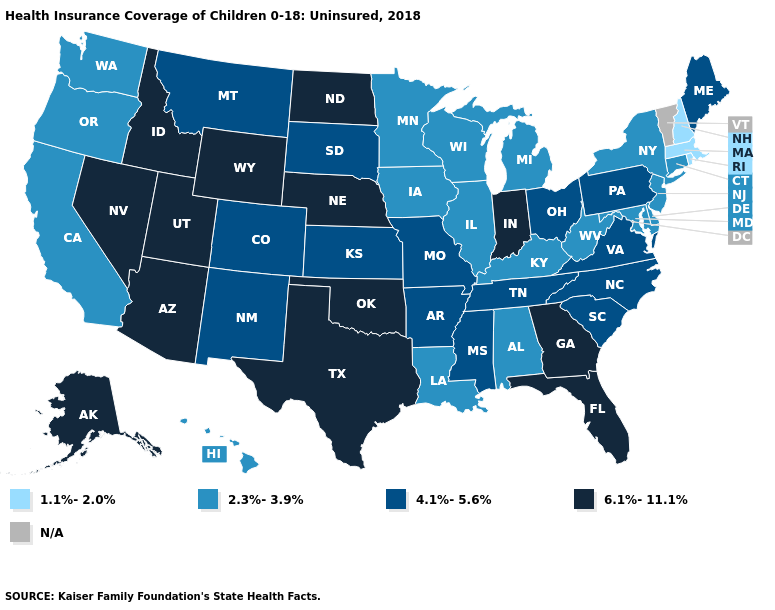Name the states that have a value in the range 4.1%-5.6%?
Concise answer only. Arkansas, Colorado, Kansas, Maine, Mississippi, Missouri, Montana, New Mexico, North Carolina, Ohio, Pennsylvania, South Carolina, South Dakota, Tennessee, Virginia. Name the states that have a value in the range 1.1%-2.0%?
Answer briefly. Massachusetts, New Hampshire, Rhode Island. Name the states that have a value in the range 4.1%-5.6%?
Be succinct. Arkansas, Colorado, Kansas, Maine, Mississippi, Missouri, Montana, New Mexico, North Carolina, Ohio, Pennsylvania, South Carolina, South Dakota, Tennessee, Virginia. How many symbols are there in the legend?
Keep it brief. 5. Does Florida have the lowest value in the South?
Be succinct. No. Name the states that have a value in the range 1.1%-2.0%?
Write a very short answer. Massachusetts, New Hampshire, Rhode Island. What is the highest value in the MidWest ?
Answer briefly. 6.1%-11.1%. How many symbols are there in the legend?
Write a very short answer. 5. What is the highest value in the USA?
Quick response, please. 6.1%-11.1%. What is the value of Massachusetts?
Quick response, please. 1.1%-2.0%. Name the states that have a value in the range 2.3%-3.9%?
Be succinct. Alabama, California, Connecticut, Delaware, Hawaii, Illinois, Iowa, Kentucky, Louisiana, Maryland, Michigan, Minnesota, New Jersey, New York, Oregon, Washington, West Virginia, Wisconsin. What is the value of Florida?
Write a very short answer. 6.1%-11.1%. 